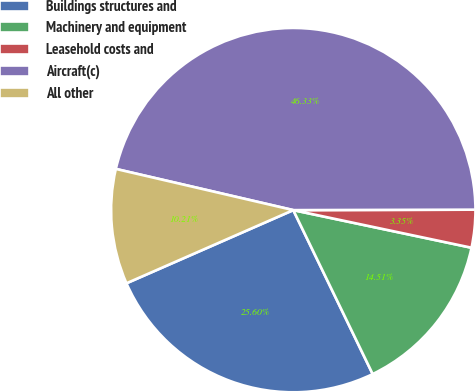<chart> <loc_0><loc_0><loc_500><loc_500><pie_chart><fcel>Buildings structures and<fcel>Machinery and equipment<fcel>Leasehold costs and<fcel>Aircraft(c)<fcel>All other<nl><fcel>25.6%<fcel>14.51%<fcel>3.35%<fcel>46.33%<fcel>10.21%<nl></chart> 